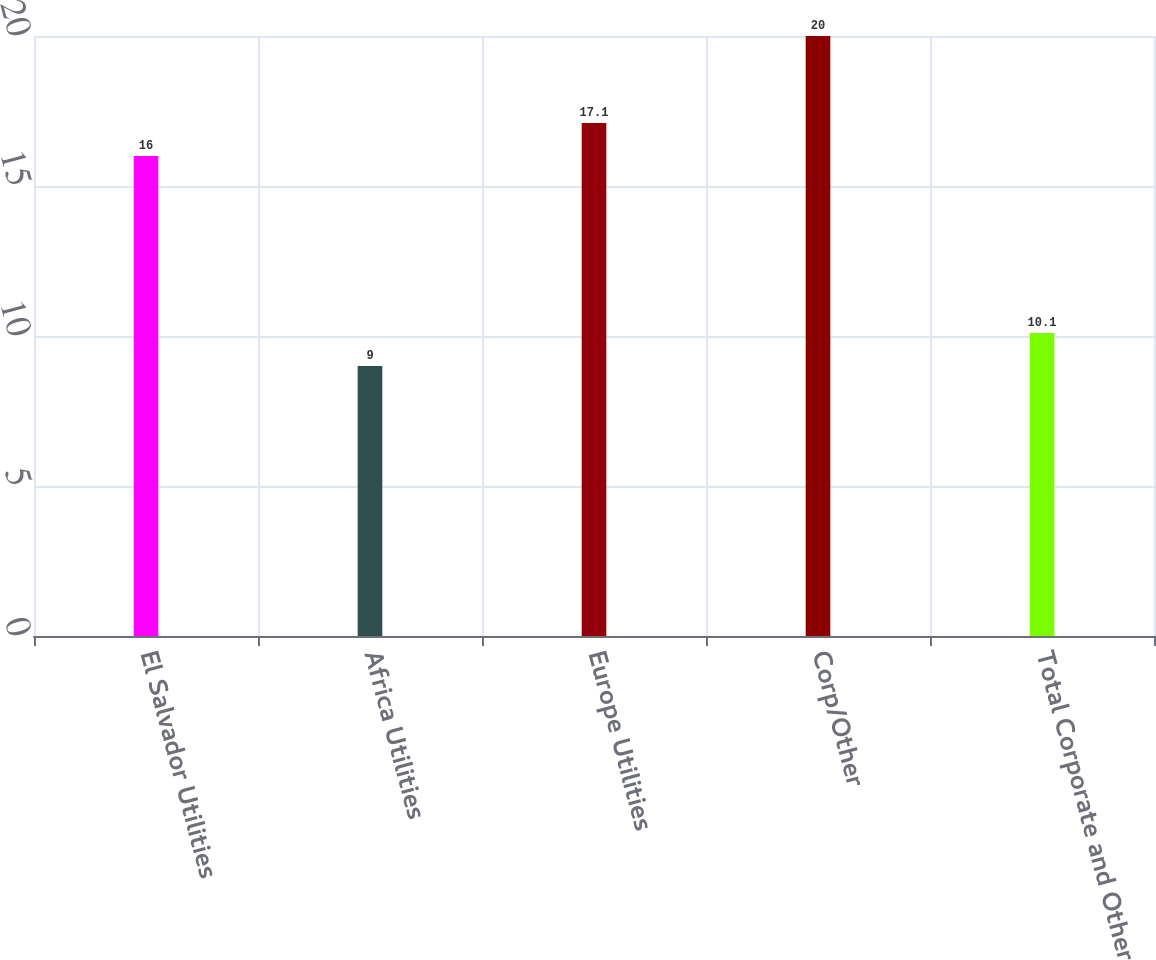Convert chart to OTSL. <chart><loc_0><loc_0><loc_500><loc_500><bar_chart><fcel>El Salvador Utilities<fcel>Africa Utilities<fcel>Europe Utilities<fcel>Corp/Other<fcel>Total Corporate and Other<nl><fcel>16<fcel>9<fcel>17.1<fcel>20<fcel>10.1<nl></chart> 